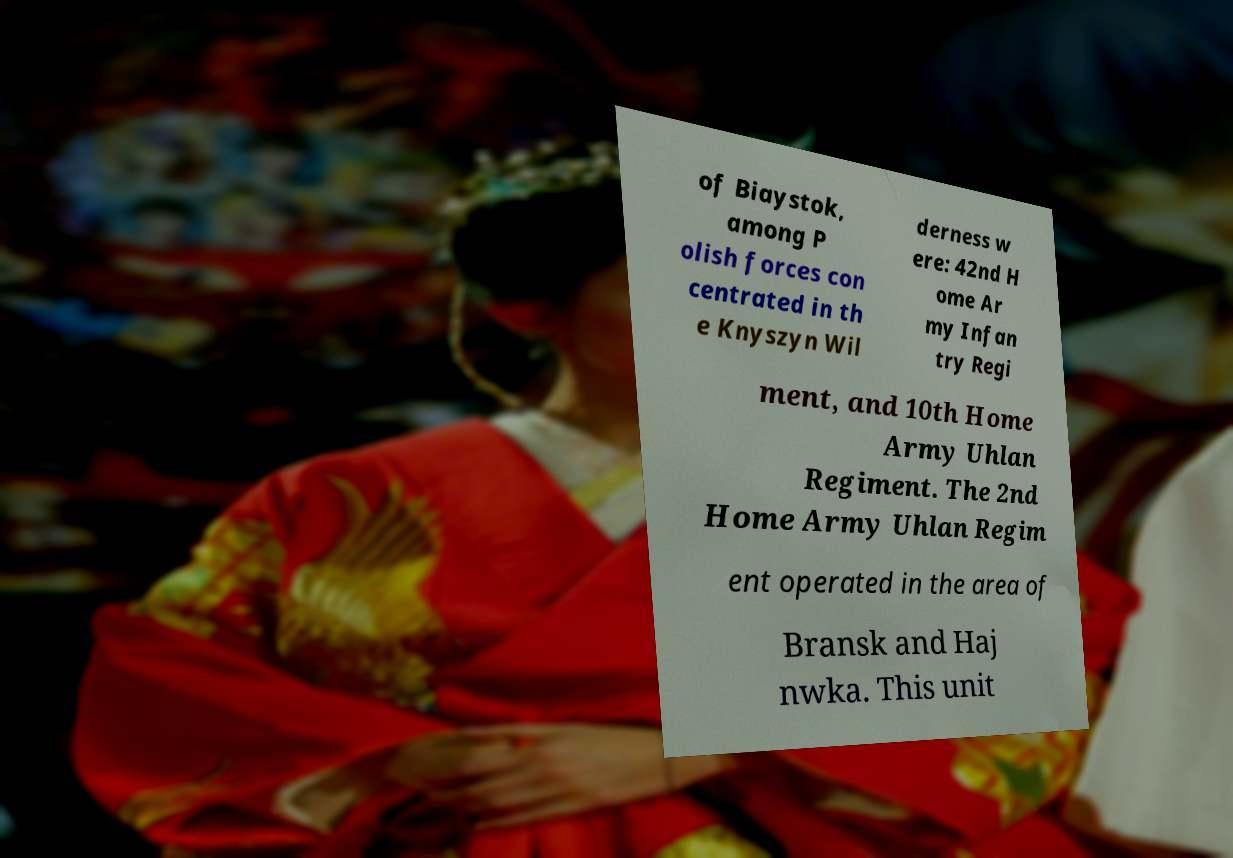Please identify and transcribe the text found in this image. of Biaystok, among P olish forces con centrated in th e Knyszyn Wil derness w ere: 42nd H ome Ar my Infan try Regi ment, and 10th Home Army Uhlan Regiment. The 2nd Home Army Uhlan Regim ent operated in the area of Bransk and Haj nwka. This unit 